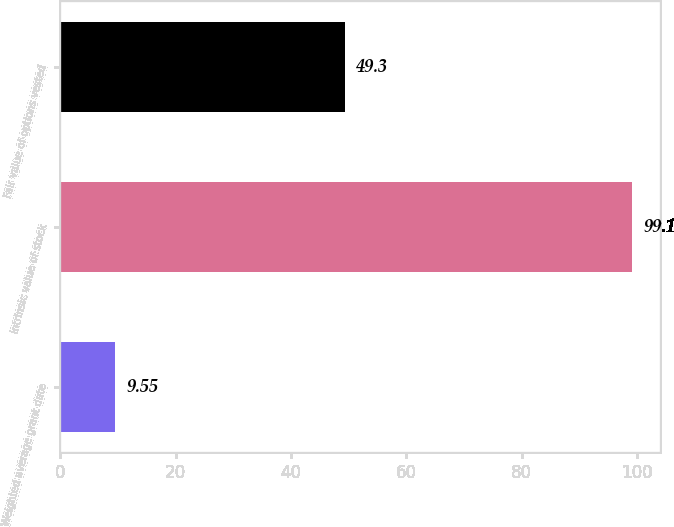Convert chart to OTSL. <chart><loc_0><loc_0><loc_500><loc_500><bar_chart><fcel>Weighted average grant date<fcel>Intrinsic value of stock<fcel>Fair value of options vested<nl><fcel>9.55<fcel>99.1<fcel>49.3<nl></chart> 